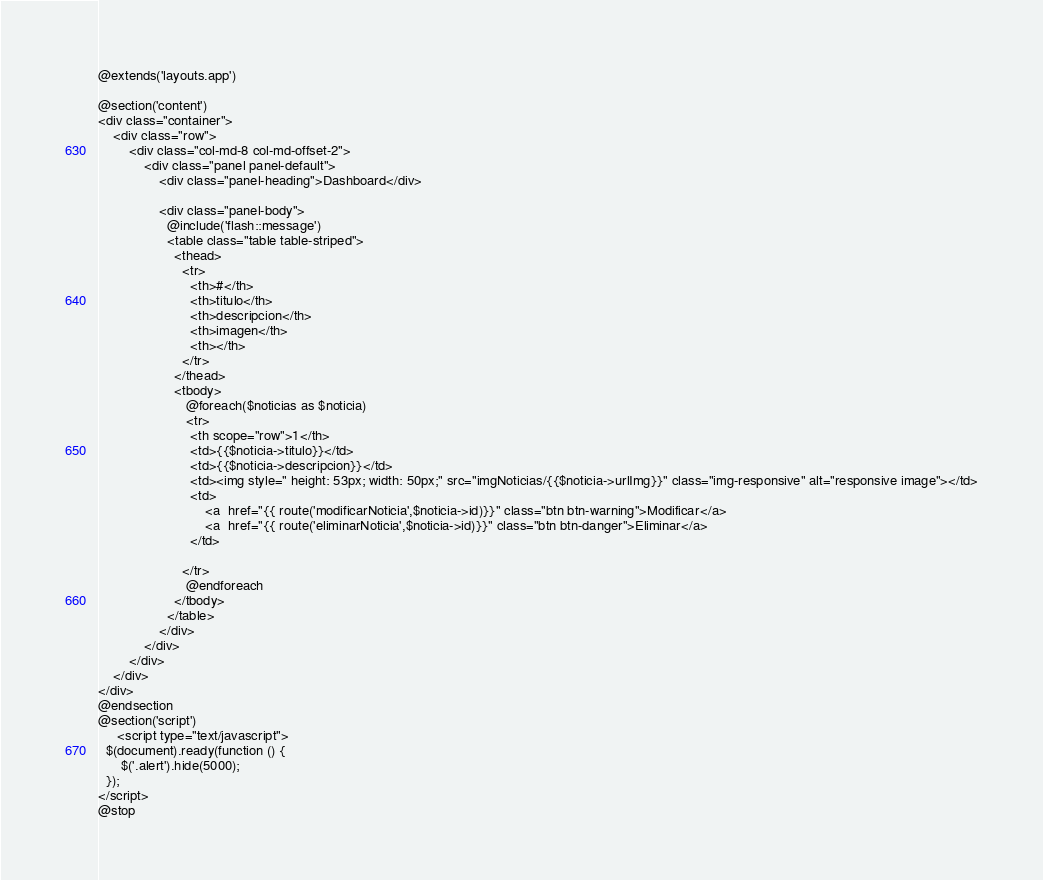Convert code to text. <code><loc_0><loc_0><loc_500><loc_500><_PHP_>@extends('layouts.app')

@section('content')
<div class="container">
    <div class="row">
        <div class="col-md-8 col-md-offset-2">
            <div class="panel panel-default">
                <div class="panel-heading">Dashboard</div>

                <div class="panel-body">                  
                  @include('flash::message')
                  <table class="table table-striped">
                    <thead>
                      <tr>
                        <th>#</th>
                        <th>titulo</th>
                        <th>descripcion</th>
                        <th>imagen</th>
                        <th></th>
                      </tr>
                    </thead>
                    <tbody>                       
                       @foreach($noticias as $noticia)
                       <tr>
                        <th scope="row">1</th>
                        <td>{{$noticia->titulo}}</td>
                        <td>{{$noticia->descripcion}}</td>
                        <td><img style=" height: 53px; width: 50px;" src="imgNoticias/{{$noticia->urlImg}}" class="img-responsive" alt="responsive image"></td>
                        <td>
                            <a  href="{{ route('modificarNoticia',$noticia->id)}}" class="btn btn-warning">Modificar</a>                         
                            <a  href="{{ route('eliminarNoticia',$noticia->id)}}" class="btn btn-danger">Eliminar</a>
                        </td>

                      </tr>
                       @endforeach
                    </tbody>
                  </table>
                </div>
            </div>
        </div>
    </div>
</div>
@endsection
@section('script')
     <script type="text/javascript">
  $(document).ready(function () {
      $('.alert').hide(5000); 
  });
</script>
@stop

</code> 